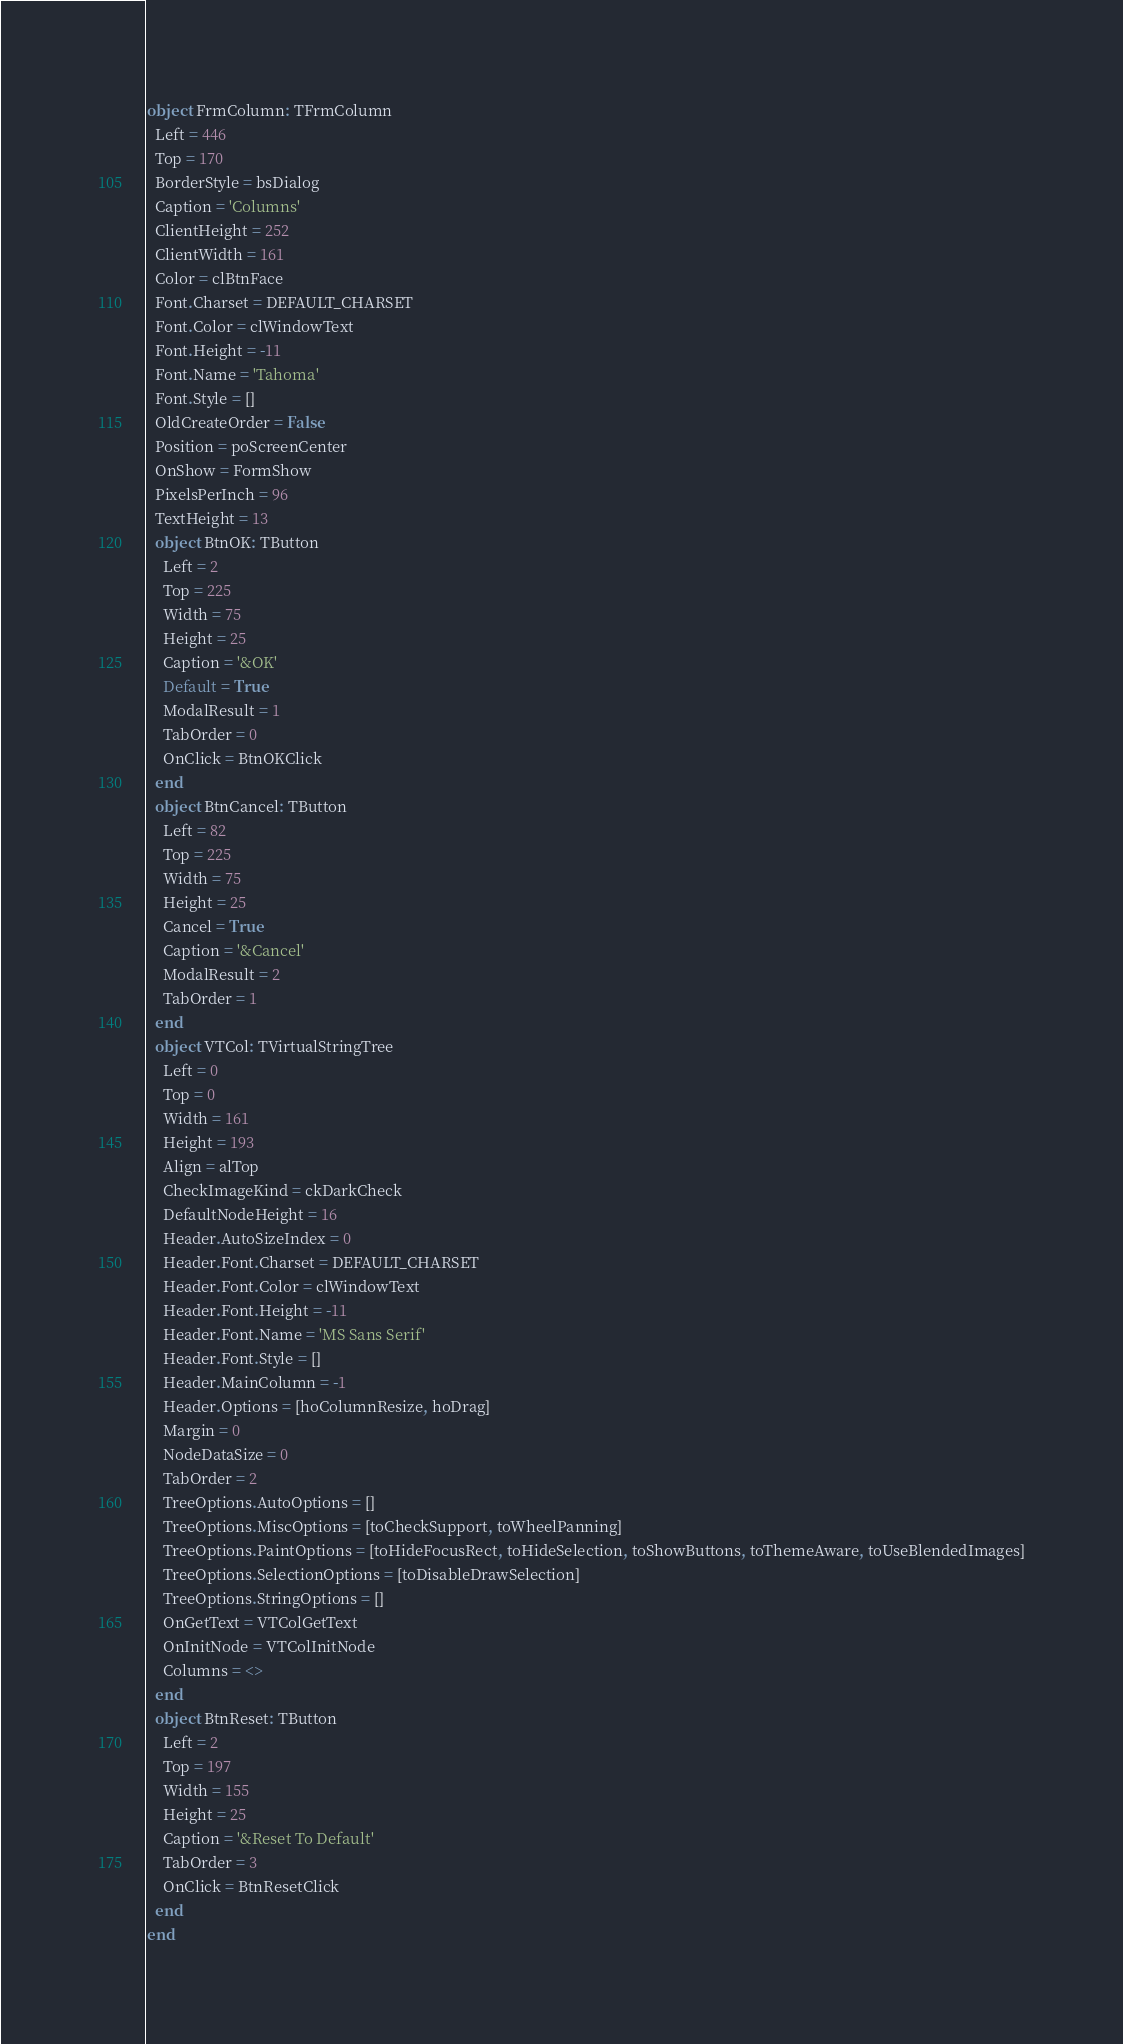Convert code to text. <code><loc_0><loc_0><loc_500><loc_500><_Pascal_>object FrmColumn: TFrmColumn
  Left = 446
  Top = 170
  BorderStyle = bsDialog
  Caption = 'Columns'
  ClientHeight = 252
  ClientWidth = 161
  Color = clBtnFace
  Font.Charset = DEFAULT_CHARSET
  Font.Color = clWindowText
  Font.Height = -11
  Font.Name = 'Tahoma'
  Font.Style = []
  OldCreateOrder = False
  Position = poScreenCenter
  OnShow = FormShow
  PixelsPerInch = 96
  TextHeight = 13
  object BtnOK: TButton
    Left = 2
    Top = 225
    Width = 75
    Height = 25
    Caption = '&OK'
    Default = True
    ModalResult = 1
    TabOrder = 0
    OnClick = BtnOKClick
  end
  object BtnCancel: TButton
    Left = 82
    Top = 225
    Width = 75
    Height = 25
    Cancel = True
    Caption = '&Cancel'
    ModalResult = 2
    TabOrder = 1
  end
  object VTCol: TVirtualStringTree
    Left = 0
    Top = 0
    Width = 161
    Height = 193
    Align = alTop
    CheckImageKind = ckDarkCheck
    DefaultNodeHeight = 16
    Header.AutoSizeIndex = 0
    Header.Font.Charset = DEFAULT_CHARSET
    Header.Font.Color = clWindowText
    Header.Font.Height = -11
    Header.Font.Name = 'MS Sans Serif'
    Header.Font.Style = []
    Header.MainColumn = -1
    Header.Options = [hoColumnResize, hoDrag]
    Margin = 0
    NodeDataSize = 0
    TabOrder = 2
    TreeOptions.AutoOptions = []
    TreeOptions.MiscOptions = [toCheckSupport, toWheelPanning]
    TreeOptions.PaintOptions = [toHideFocusRect, toHideSelection, toShowButtons, toThemeAware, toUseBlendedImages]
    TreeOptions.SelectionOptions = [toDisableDrawSelection]
    TreeOptions.StringOptions = []
    OnGetText = VTColGetText
    OnInitNode = VTColInitNode
    Columns = <>
  end
  object BtnReset: TButton
    Left = 2
    Top = 197
    Width = 155
    Height = 25
    Caption = '&Reset To Default'
    TabOrder = 3
    OnClick = BtnResetClick
  end
end
</code> 